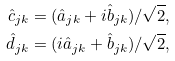Convert formula to latex. <formula><loc_0><loc_0><loc_500><loc_500>\hat { c } _ { j k } & = ( \hat { a } _ { j k } + i \hat { b } _ { j k } ) / \sqrt { 2 } , \\ \hat { d } _ { j k } & = ( i \hat { a } _ { j k } + \hat { b } _ { j k } ) / \sqrt { 2 } ,</formula> 